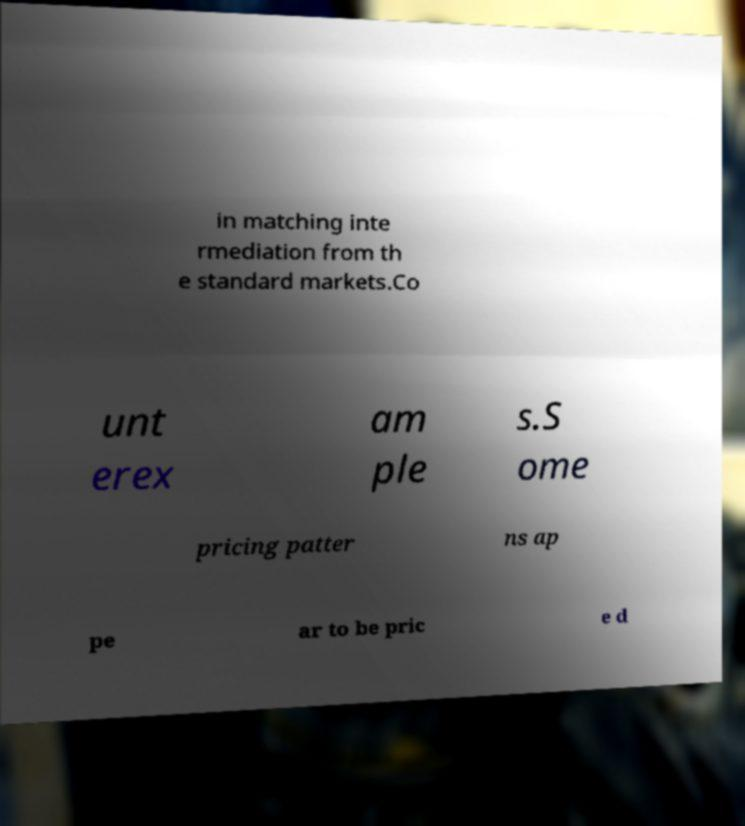Can you accurately transcribe the text from the provided image for me? in matching inte rmediation from th e standard markets.Co unt erex am ple s.S ome pricing patter ns ap pe ar to be pric e d 